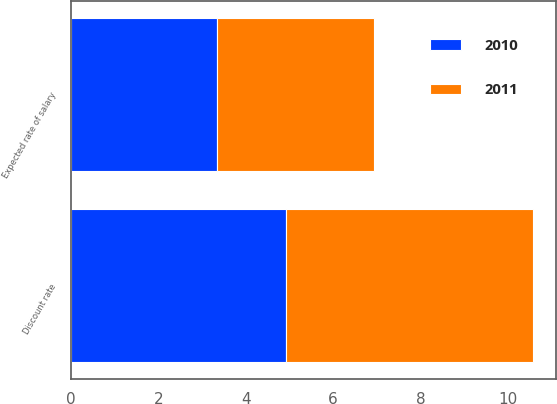Convert chart. <chart><loc_0><loc_0><loc_500><loc_500><stacked_bar_chart><ecel><fcel>Discount rate<fcel>Expected rate of salary<nl><fcel>2010<fcel>4.92<fcel>3.34<nl><fcel>2011<fcel>5.65<fcel>3.6<nl></chart> 